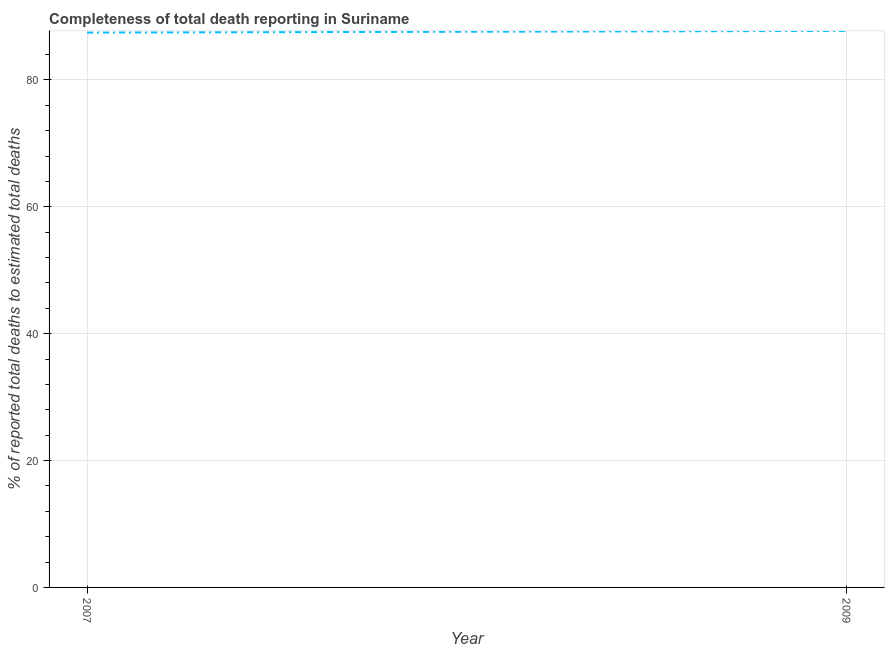What is the completeness of total death reports in 2009?
Keep it short and to the point. 87.72. Across all years, what is the maximum completeness of total death reports?
Keep it short and to the point. 87.72. Across all years, what is the minimum completeness of total death reports?
Keep it short and to the point. 87.45. In which year was the completeness of total death reports maximum?
Make the answer very short. 2009. In which year was the completeness of total death reports minimum?
Keep it short and to the point. 2007. What is the sum of the completeness of total death reports?
Offer a terse response. 175.17. What is the difference between the completeness of total death reports in 2007 and 2009?
Provide a short and direct response. -0.27. What is the average completeness of total death reports per year?
Your answer should be very brief. 87.59. What is the median completeness of total death reports?
Ensure brevity in your answer.  87.59. In how many years, is the completeness of total death reports greater than 76 %?
Offer a terse response. 2. Do a majority of the years between 2009 and 2007 (inclusive) have completeness of total death reports greater than 40 %?
Make the answer very short. No. What is the ratio of the completeness of total death reports in 2007 to that in 2009?
Keep it short and to the point. 1. In how many years, is the completeness of total death reports greater than the average completeness of total death reports taken over all years?
Give a very brief answer. 1. Does the completeness of total death reports monotonically increase over the years?
Your answer should be very brief. Yes. How many lines are there?
Make the answer very short. 1. Does the graph contain any zero values?
Provide a succinct answer. No. Does the graph contain grids?
Your response must be concise. Yes. What is the title of the graph?
Your answer should be compact. Completeness of total death reporting in Suriname. What is the label or title of the X-axis?
Your answer should be very brief. Year. What is the label or title of the Y-axis?
Your response must be concise. % of reported total deaths to estimated total deaths. What is the % of reported total deaths to estimated total deaths in 2007?
Your answer should be compact. 87.45. What is the % of reported total deaths to estimated total deaths in 2009?
Provide a short and direct response. 87.72. What is the difference between the % of reported total deaths to estimated total deaths in 2007 and 2009?
Keep it short and to the point. -0.27. What is the ratio of the % of reported total deaths to estimated total deaths in 2007 to that in 2009?
Offer a terse response. 1. 